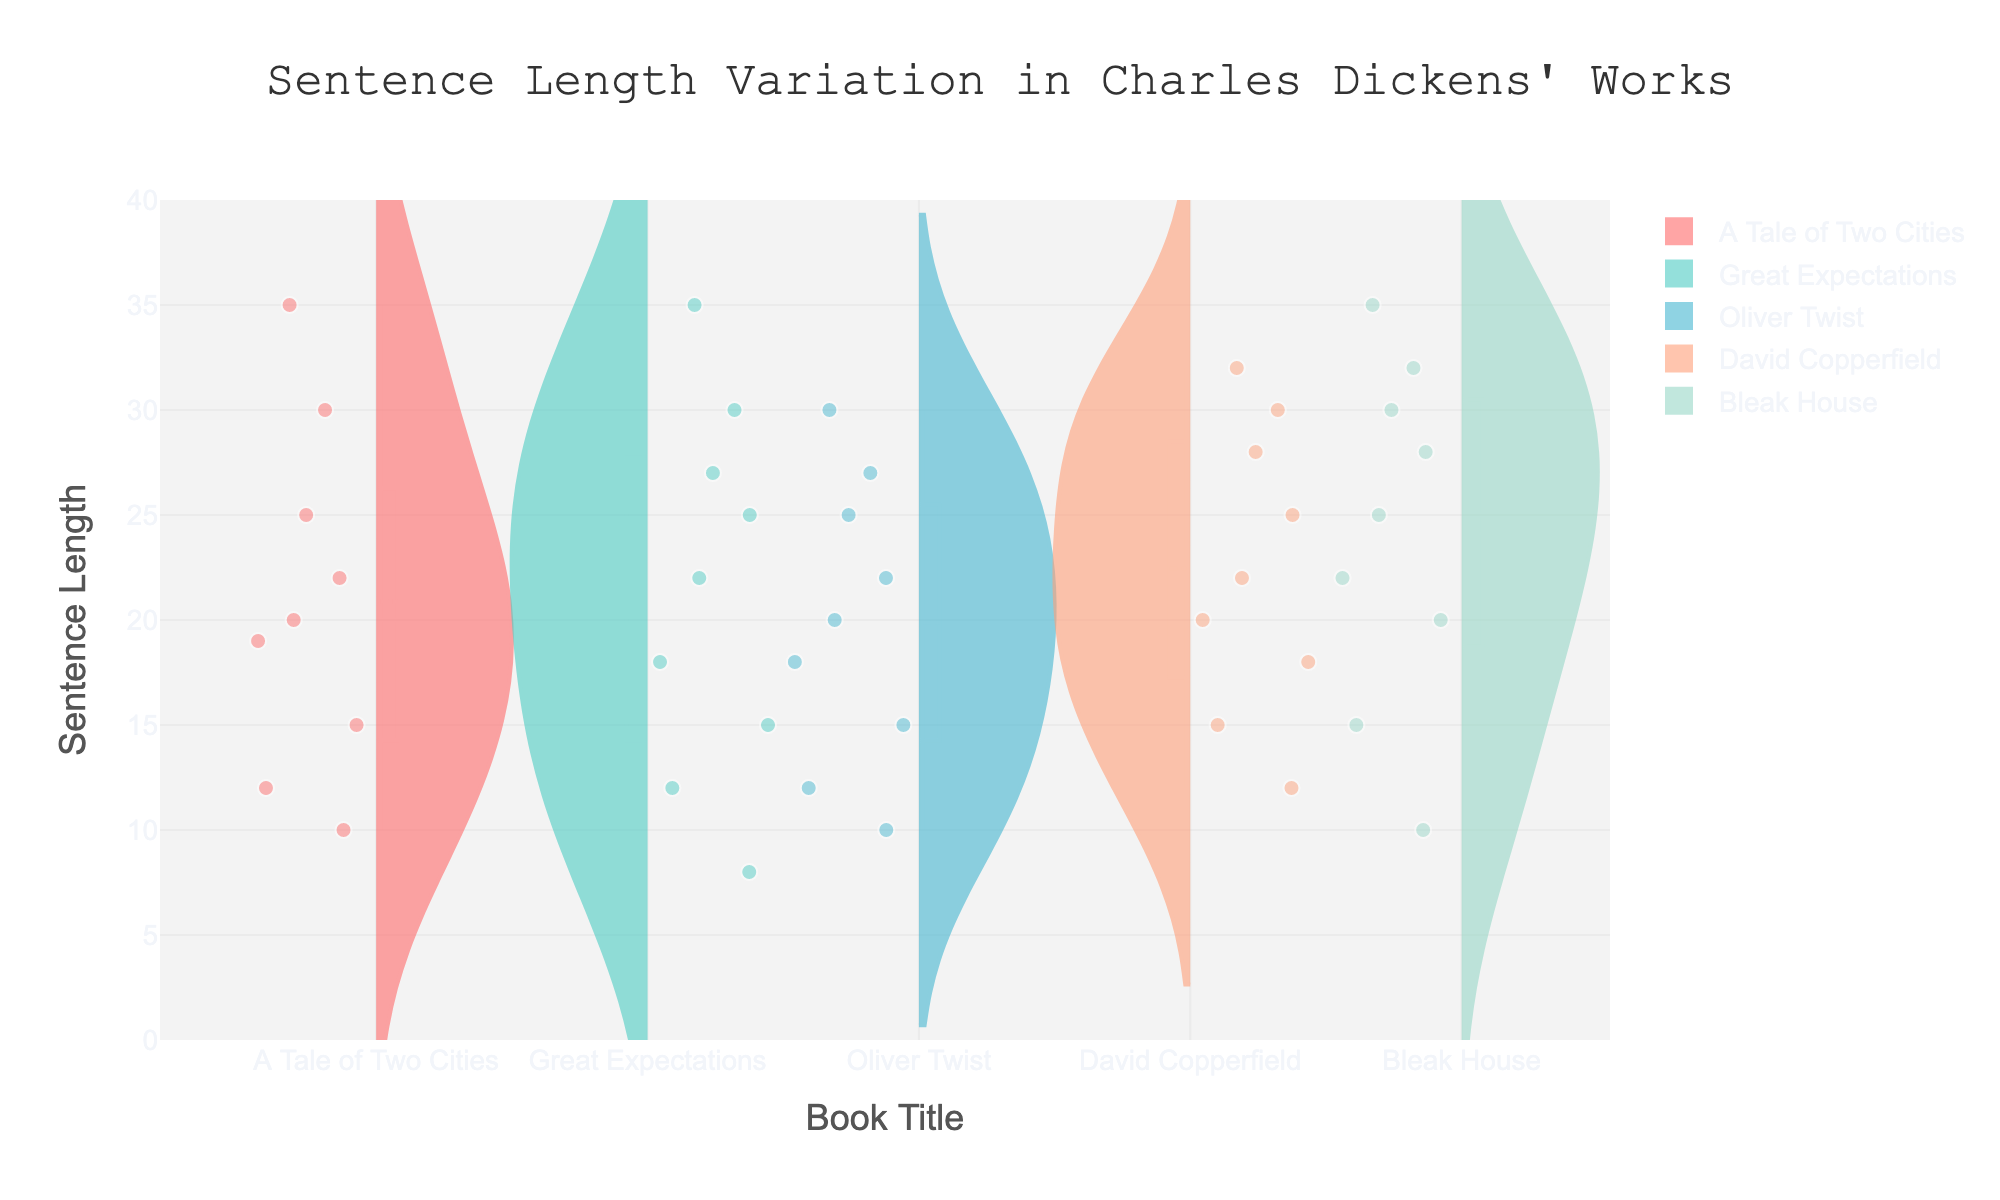What is the title of the plot? The title of the plot is displayed at the top center and typically provides an overview of what the plot represents. By reading the text at the top, you can see the title "Sentence Length Variation in Charles Dickens' Works."
Answer: Sentence Length Variation in Charles Dickens' Works Which book shows the greatest variation in sentence length? To determine the book with the greatest variation in sentence length, look at the width of the violins. "Bleak House" has a wider spread of data points ranging from around 10 to 35, indicating the greatest variation.
Answer: Bleak House How many books are compared in this figure? Count the number of distinct violin plots present in the figure, each representing a different book. There are five distinct violin plots.
Answer: Five Which book has the shortest sentence length and what is it? The shortest sentence length will be represented by the lowest point in the violin plots. For "Great Expectations," the minimum sentence length is 8.
Answer: Great Expectations, 8 Compare the median sentence lengths of "A Tale of Two Cities" and "Oliver Twist." Which one is higher? The median sentence length is indicated by the white line inside each violin. "A Tale of Two Cities" has a median around 20, while "Oliver Twist" has a median closer to 18.
Answer: A Tale of Two Cities What is the range of sentence lengths for "David Copperfield"? Identify the minimum and maximum points within the violin for "David Copperfield." The range is from 12 to 32.
Answer: 12 to 32 Which book has the most consistently similar sentence lengths? Look for the violin plot with the least spread. "Great Expectations" has a more consistent clustering of sentences around a central value.
Answer: Great Expectations Is there any book with a mean sentence length of exactly 25? The mean sentence length is shown by a dashed line within each violin. Both "Bleak House" and "David Copperfield" have mean lines crossing at 25.
Answer: Bleak House and David Copperfield What sentence length is most frequently observed in "Oliver Twist"? The density of the violin plot highlights the most frequent data points. In "Oliver Twist," the highest density occurs around 22.
Answer: 22 Compare the distributions of "A Tale of Two Cities" and "Great Expectations." Which has a wider interquartile range (IQR)? The IQR is the range between the first and third quartile, captured by the width of the box. "A Tale of Two Cities" has a wider IQR compared to "Great Expectations."
Answer: A Tale of Two Cities 